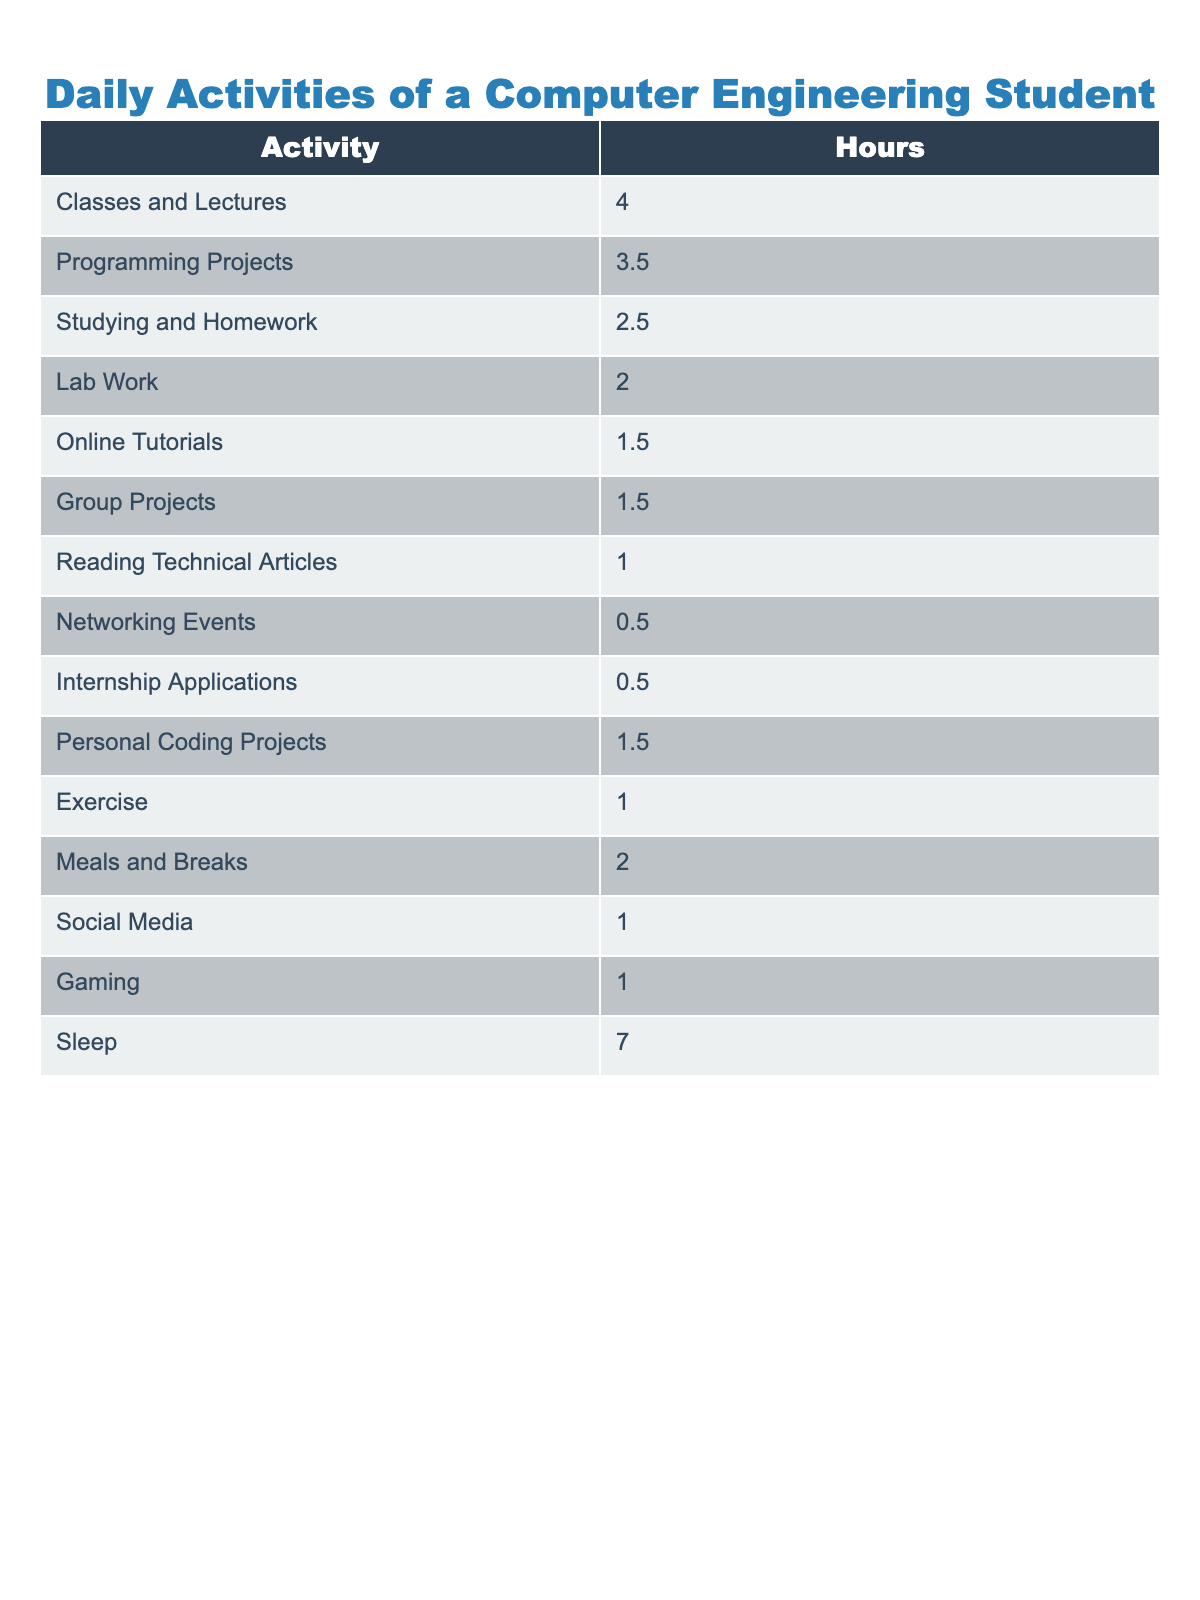What is the total number of hours a computer engineering student spends on classes and lectures? The table shows that the student spends 4 hours on classes and lectures, which is directly stated under the "Hours" column for that activity.
Answer: 4 hours How many hours does a computer engineering student spend on programming projects? According to the table, the student spends 3.5 hours on programming projects, which is explicitly listed in the "Hours" column for that activity.
Answer: 3.5 hours What activity takes the most time after sleep? Looking at the table, sleep takes 7 hours, and the next highest activity is classes and lectures, which takes 4 hours. This implies that classes and lectures take the most time after sleep.
Answer: Classes and lectures What is the total time spent on all project-related activities? To determine this, I will sum the hours for "Programming Projects," "Group Projects," and "Personal Coding Projects": 3.5 + 1.5 + 1.5 = 6.5 hours.
Answer: 6.5 hours How much time does the student dedicate to studying compared to programming? The table indicates 2.5 hours for studying and 3.5 hours for programming. The difference is 3.5 - 2.5 = 1 hour more spent on programming than studying.
Answer: 1 hour Is the time spent on meals and breaks more than the time spent on online tutorials? The table shows 2 hours for meals and breaks and 1.5 hours for online tutorials. Since 2 is greater than 1.5, the statement is true.
Answer: Yes What percentage of the student's day is spent sleeping? The total hours in a day is 24. The student spends 7 hours sleeping. To find the percentage, we calculate (7/24) * 100, which is approximately 29.17%.
Answer: 29.17% How much time does the student spend on social media compared to exercise? The student spends 1 hour on social media and 1 hour on exercise. They spend equal time on both activities since 1 is equal to 1.
Answer: Equal time What is the total time spent on all academic-related activities (classes, programming projects, studying, and lab work)? I will add the hours for "Classes and Lectures" (4), "Programming Projects" (3.5), "Studying and Homework" (2.5), and "Lab Work" (2). The total is 4 + 3.5 + 2.5 + 2 = 12 hours.
Answer: 12 hours Which activity has the least time spent? Examining the table, "Networking Events" and "Internship Applications" both have 0.5 hours, which is the least. Thus, these activities share the least time spent.
Answer: Networking Events and Internship Applications 